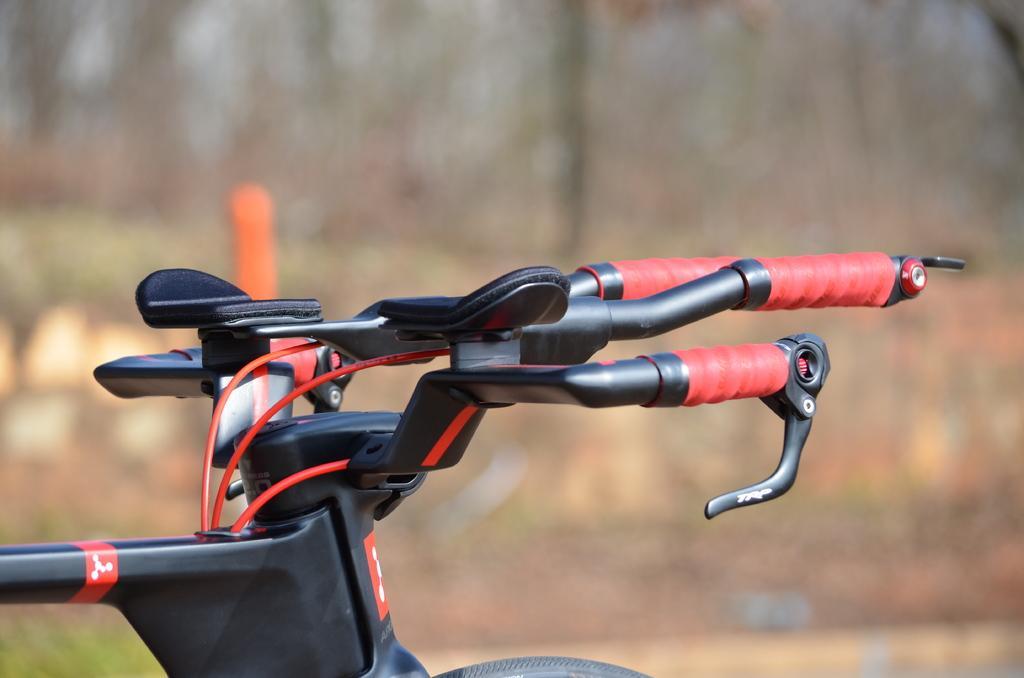How would you summarize this image in a sentence or two? In this image there is a bicycle. Background there are few trees and plants on the land. 